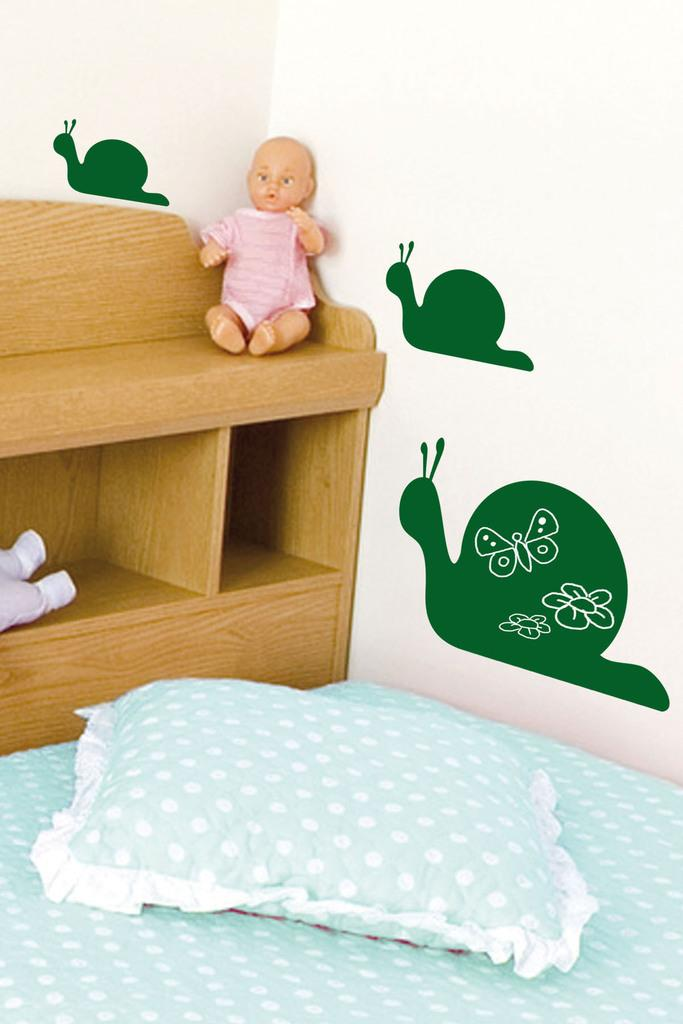What piece of furniture is present in the image? There is a bed in the image. What is placed on the bed? There is a pillow on the bed. Where is the doll located in the image? The doll is on a wooden desk. What can be seen in the background of the image? There is a wall in the background of the image. What is printed on the wall? There is a snail printed on the wall. What type of ship can be seen sailing in the image? There is no ship present in the image; it features a bed, a pillow, a doll on a wooden desk, and a wall with a snail print. What behavior is the snail exhibiting in the image? The snail is not exhibiting any behavior in the image, as it is a printed image on the wall. 